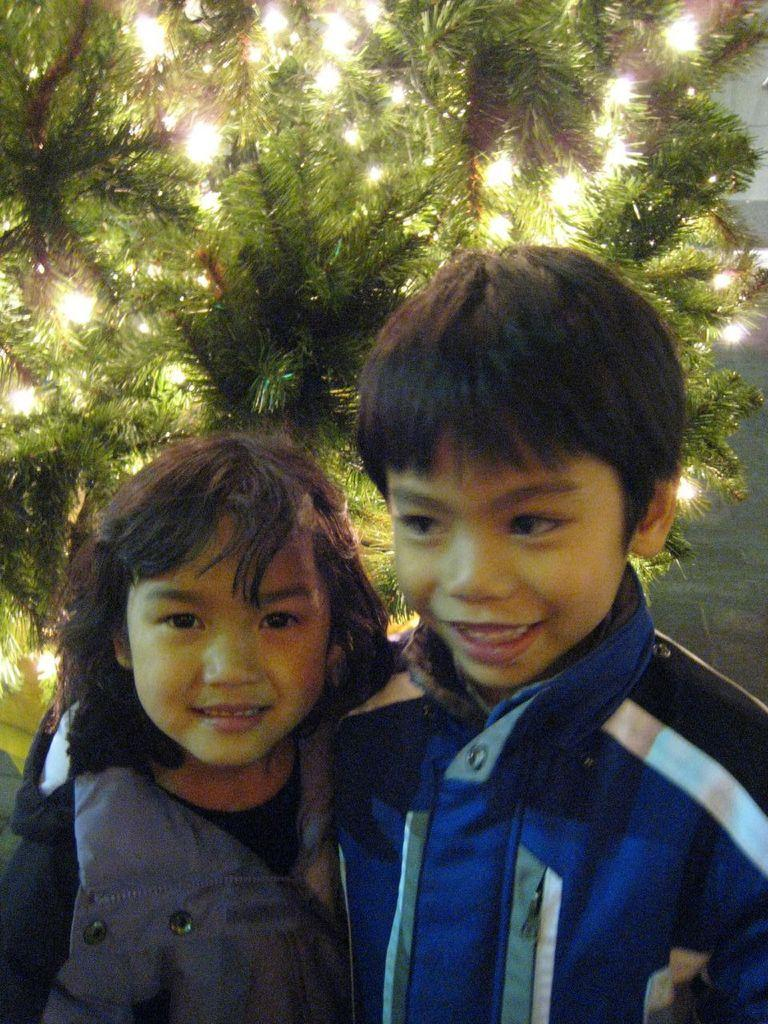How many people are present in the image? There are two people in the image. What are the people wearing? The people are wearing different color dresses. What is the main object in the background of the image? There is a Christmas tree in the image. Are there any decorations on the Christmas tree? Yes, there are lights on the Christmas tree. What type of chalk is being used to draw on the wall in the image? There is no chalk or drawing on the wall present in the image. Can you tell me how many twigs are on the Christmas tree in the image? There are no twigs mentioned or visible on the Christmas tree in the image; it has lights instead. 